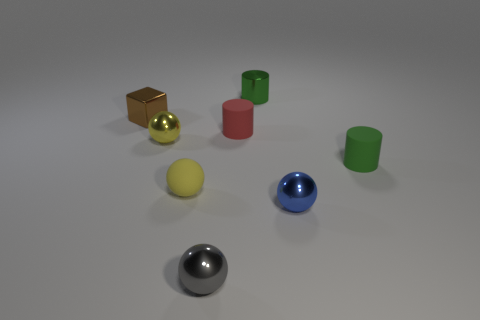What material is the other yellow thing that is the same shape as the yellow metal object?
Your response must be concise. Rubber. What material is the other ball that is the same color as the rubber sphere?
Offer a terse response. Metal. Is the number of small matte spheres less than the number of small cyan shiny cylinders?
Provide a succinct answer. No. Is the color of the tiny metal thing that is behind the small cube the same as the cube?
Give a very brief answer. No. What is the color of the cylinder that is the same material as the red thing?
Your answer should be compact. Green. Do the gray metallic object and the blue metal sphere have the same size?
Provide a short and direct response. Yes. What is the small blue ball made of?
Keep it short and to the point. Metal. What material is the brown block that is the same size as the gray metal ball?
Your answer should be compact. Metal. Is there a sphere of the same size as the green metallic cylinder?
Make the answer very short. Yes. Are there the same number of brown cubes that are right of the small gray metal object and tiny gray metal things that are on the left side of the metallic cylinder?
Your answer should be compact. No. 